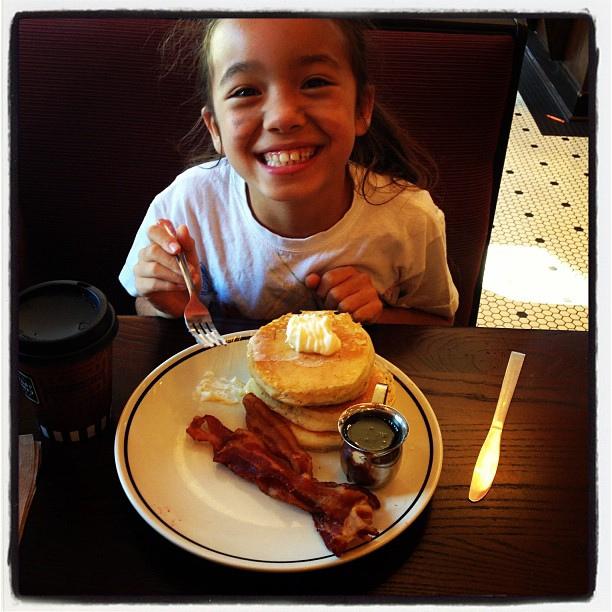What is lying on the table near the plate?
Short answer required. Knife. How many dots are on the floor?
Be succinct. 15. What meal is she going to eat?
Give a very brief answer. Breakfast. 